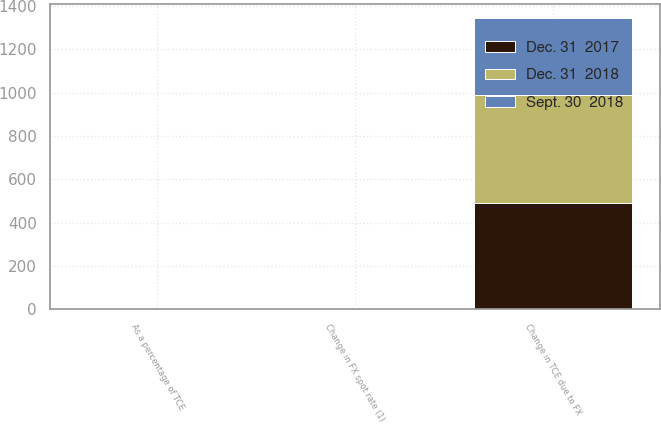<chart> <loc_0><loc_0><loc_500><loc_500><stacked_bar_chart><ecel><fcel>Change in FX spot rate (1)<fcel>Change in TCE due to FX<fcel>As a percentage of TCE<nl><fcel>Dec. 31  2017<fcel>1.6<fcel>491<fcel>0.3<nl><fcel>Sept. 30  2018<fcel>0.2<fcel>354<fcel>0.2<nl><fcel>Dec. 31  2018<fcel>1.2<fcel>498<fcel>0.3<nl></chart> 